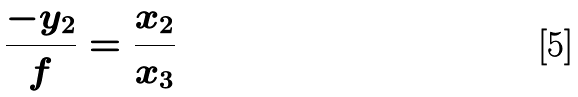<formula> <loc_0><loc_0><loc_500><loc_500>\frac { - y _ { 2 } } { f } = \frac { x _ { 2 } } { x _ { 3 } }</formula> 